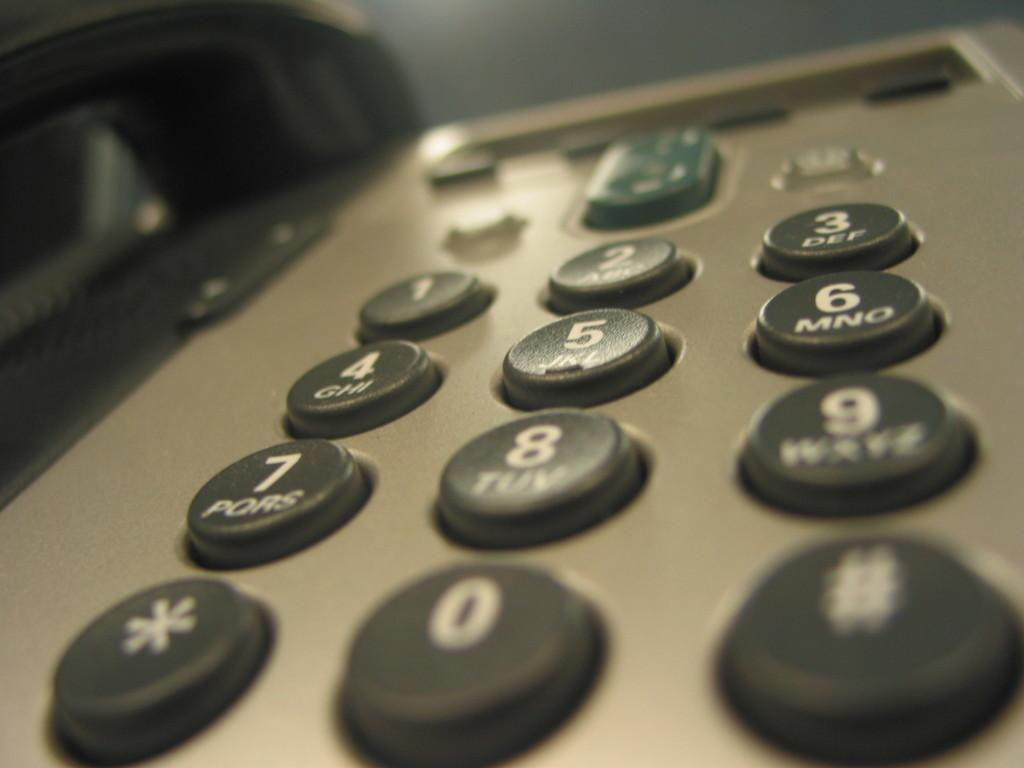Provide a one-sentence caption for the provided image. A silver telephone with black buttons has a green button above the button with a 2 on it. 